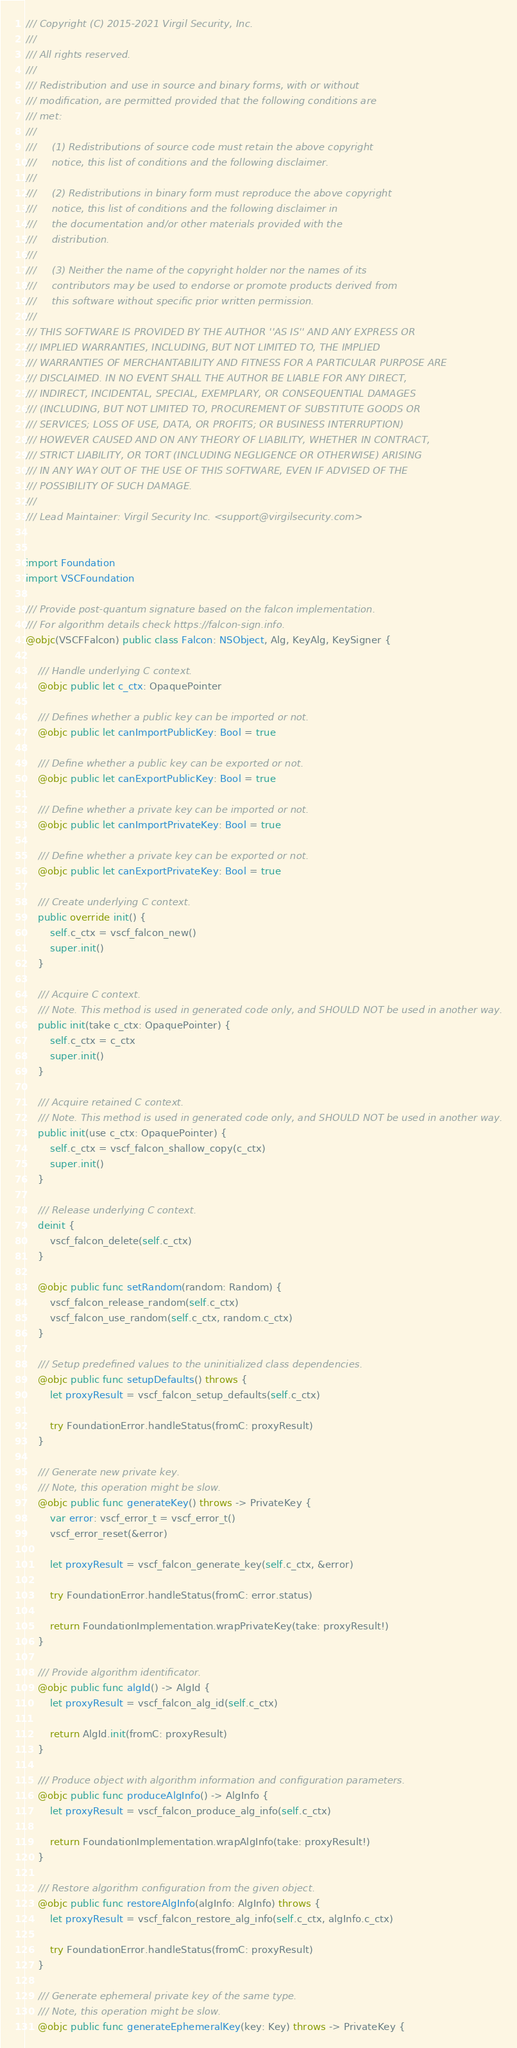Convert code to text. <code><loc_0><loc_0><loc_500><loc_500><_Swift_>/// Copyright (C) 2015-2021 Virgil Security, Inc.
///
/// All rights reserved.
///
/// Redistribution and use in source and binary forms, with or without
/// modification, are permitted provided that the following conditions are
/// met:
///
///     (1) Redistributions of source code must retain the above copyright
///     notice, this list of conditions and the following disclaimer.
///
///     (2) Redistributions in binary form must reproduce the above copyright
///     notice, this list of conditions and the following disclaimer in
///     the documentation and/or other materials provided with the
///     distribution.
///
///     (3) Neither the name of the copyright holder nor the names of its
///     contributors may be used to endorse or promote products derived from
///     this software without specific prior written permission.
///
/// THIS SOFTWARE IS PROVIDED BY THE AUTHOR ''AS IS'' AND ANY EXPRESS OR
/// IMPLIED WARRANTIES, INCLUDING, BUT NOT LIMITED TO, THE IMPLIED
/// WARRANTIES OF MERCHANTABILITY AND FITNESS FOR A PARTICULAR PURPOSE ARE
/// DISCLAIMED. IN NO EVENT SHALL THE AUTHOR BE LIABLE FOR ANY DIRECT,
/// INDIRECT, INCIDENTAL, SPECIAL, EXEMPLARY, OR CONSEQUENTIAL DAMAGES
/// (INCLUDING, BUT NOT LIMITED TO, PROCUREMENT OF SUBSTITUTE GOODS OR
/// SERVICES; LOSS OF USE, DATA, OR PROFITS; OR BUSINESS INTERRUPTION)
/// HOWEVER CAUSED AND ON ANY THEORY OF LIABILITY, WHETHER IN CONTRACT,
/// STRICT LIABILITY, OR TORT (INCLUDING NEGLIGENCE OR OTHERWISE) ARISING
/// IN ANY WAY OUT OF THE USE OF THIS SOFTWARE, EVEN IF ADVISED OF THE
/// POSSIBILITY OF SUCH DAMAGE.
///
/// Lead Maintainer: Virgil Security Inc. <support@virgilsecurity.com>


import Foundation
import VSCFoundation

/// Provide post-quantum signature based on the falcon implementation.
/// For algorithm details check https://falcon-sign.info.
@objc(VSCFFalcon) public class Falcon: NSObject, Alg, KeyAlg, KeySigner {

    /// Handle underlying C context.
    @objc public let c_ctx: OpaquePointer

    /// Defines whether a public key can be imported or not.
    @objc public let canImportPublicKey: Bool = true

    /// Define whether a public key can be exported or not.
    @objc public let canExportPublicKey: Bool = true

    /// Define whether a private key can be imported or not.
    @objc public let canImportPrivateKey: Bool = true

    /// Define whether a private key can be exported or not.
    @objc public let canExportPrivateKey: Bool = true

    /// Create underlying C context.
    public override init() {
        self.c_ctx = vscf_falcon_new()
        super.init()
    }

    /// Acquire C context.
    /// Note. This method is used in generated code only, and SHOULD NOT be used in another way.
    public init(take c_ctx: OpaquePointer) {
        self.c_ctx = c_ctx
        super.init()
    }

    /// Acquire retained C context.
    /// Note. This method is used in generated code only, and SHOULD NOT be used in another way.
    public init(use c_ctx: OpaquePointer) {
        self.c_ctx = vscf_falcon_shallow_copy(c_ctx)
        super.init()
    }

    /// Release underlying C context.
    deinit {
        vscf_falcon_delete(self.c_ctx)
    }

    @objc public func setRandom(random: Random) {
        vscf_falcon_release_random(self.c_ctx)
        vscf_falcon_use_random(self.c_ctx, random.c_ctx)
    }

    /// Setup predefined values to the uninitialized class dependencies.
    @objc public func setupDefaults() throws {
        let proxyResult = vscf_falcon_setup_defaults(self.c_ctx)

        try FoundationError.handleStatus(fromC: proxyResult)
    }

    /// Generate new private key.
    /// Note, this operation might be slow.
    @objc public func generateKey() throws -> PrivateKey {
        var error: vscf_error_t = vscf_error_t()
        vscf_error_reset(&error)

        let proxyResult = vscf_falcon_generate_key(self.c_ctx, &error)

        try FoundationError.handleStatus(fromC: error.status)

        return FoundationImplementation.wrapPrivateKey(take: proxyResult!)
    }

    /// Provide algorithm identificator.
    @objc public func algId() -> AlgId {
        let proxyResult = vscf_falcon_alg_id(self.c_ctx)

        return AlgId.init(fromC: proxyResult)
    }

    /// Produce object with algorithm information and configuration parameters.
    @objc public func produceAlgInfo() -> AlgInfo {
        let proxyResult = vscf_falcon_produce_alg_info(self.c_ctx)

        return FoundationImplementation.wrapAlgInfo(take: proxyResult!)
    }

    /// Restore algorithm configuration from the given object.
    @objc public func restoreAlgInfo(algInfo: AlgInfo) throws {
        let proxyResult = vscf_falcon_restore_alg_info(self.c_ctx, algInfo.c_ctx)

        try FoundationError.handleStatus(fromC: proxyResult)
    }

    /// Generate ephemeral private key of the same type.
    /// Note, this operation might be slow.
    @objc public func generateEphemeralKey(key: Key) throws -> PrivateKey {</code> 